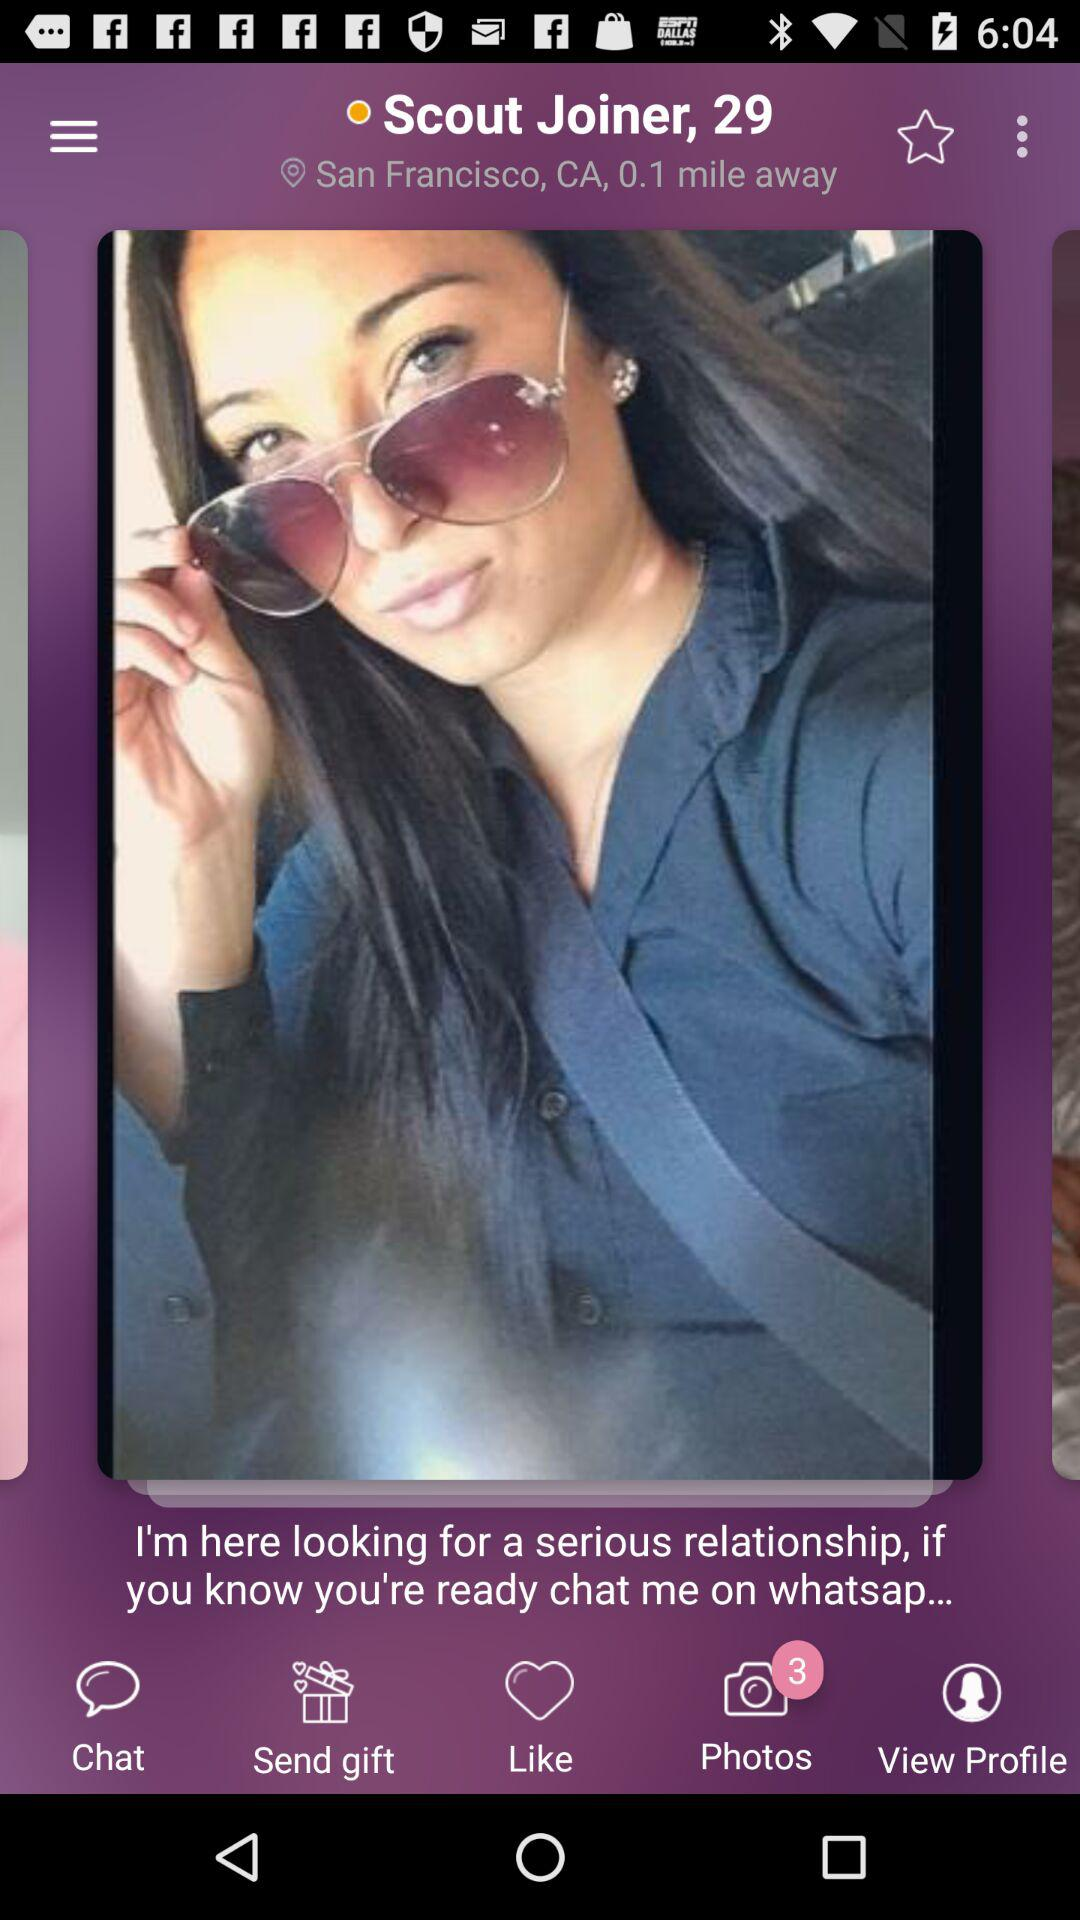What is the location given on the screen? The location is San Francisco, CA. 